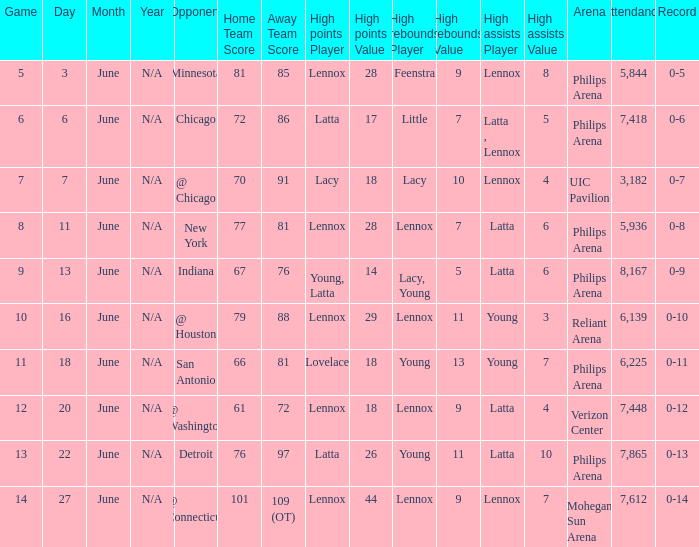What stadium hosted the June 7 game and how many visitors were there? UIC Pavilion 3,182. 